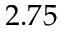Convert formula to latex. <formula><loc_0><loc_0><loc_500><loc_500>2 . 7 5</formula> 